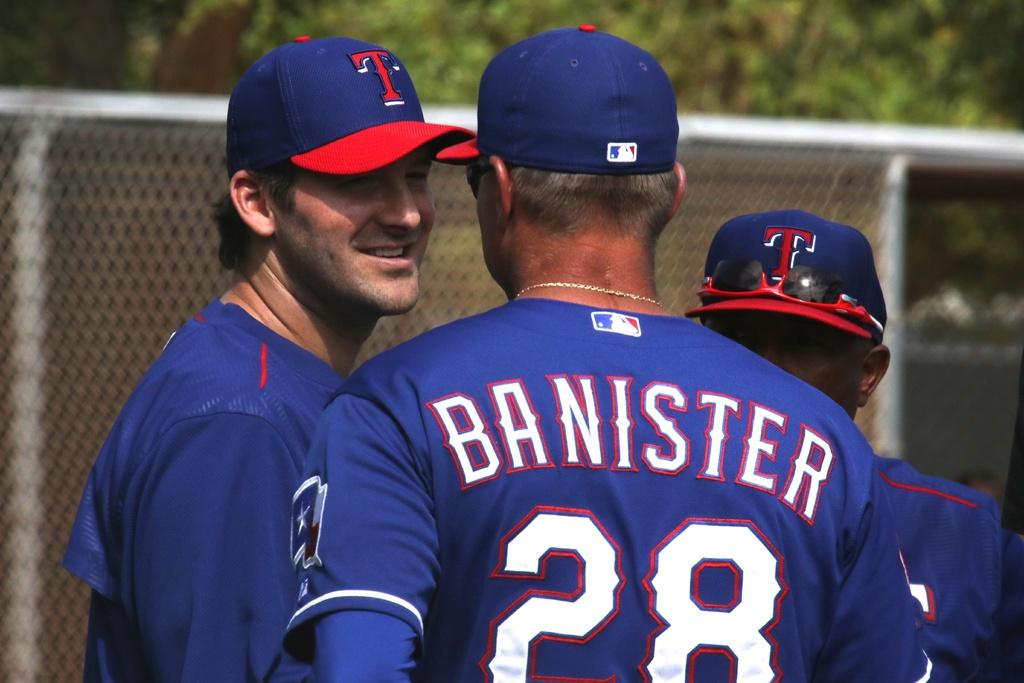<image>
Present a compact description of the photo's key features. A baseball player Banister is talking with a teammate. 